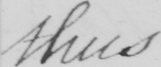Can you read and transcribe this handwriting? thus- 